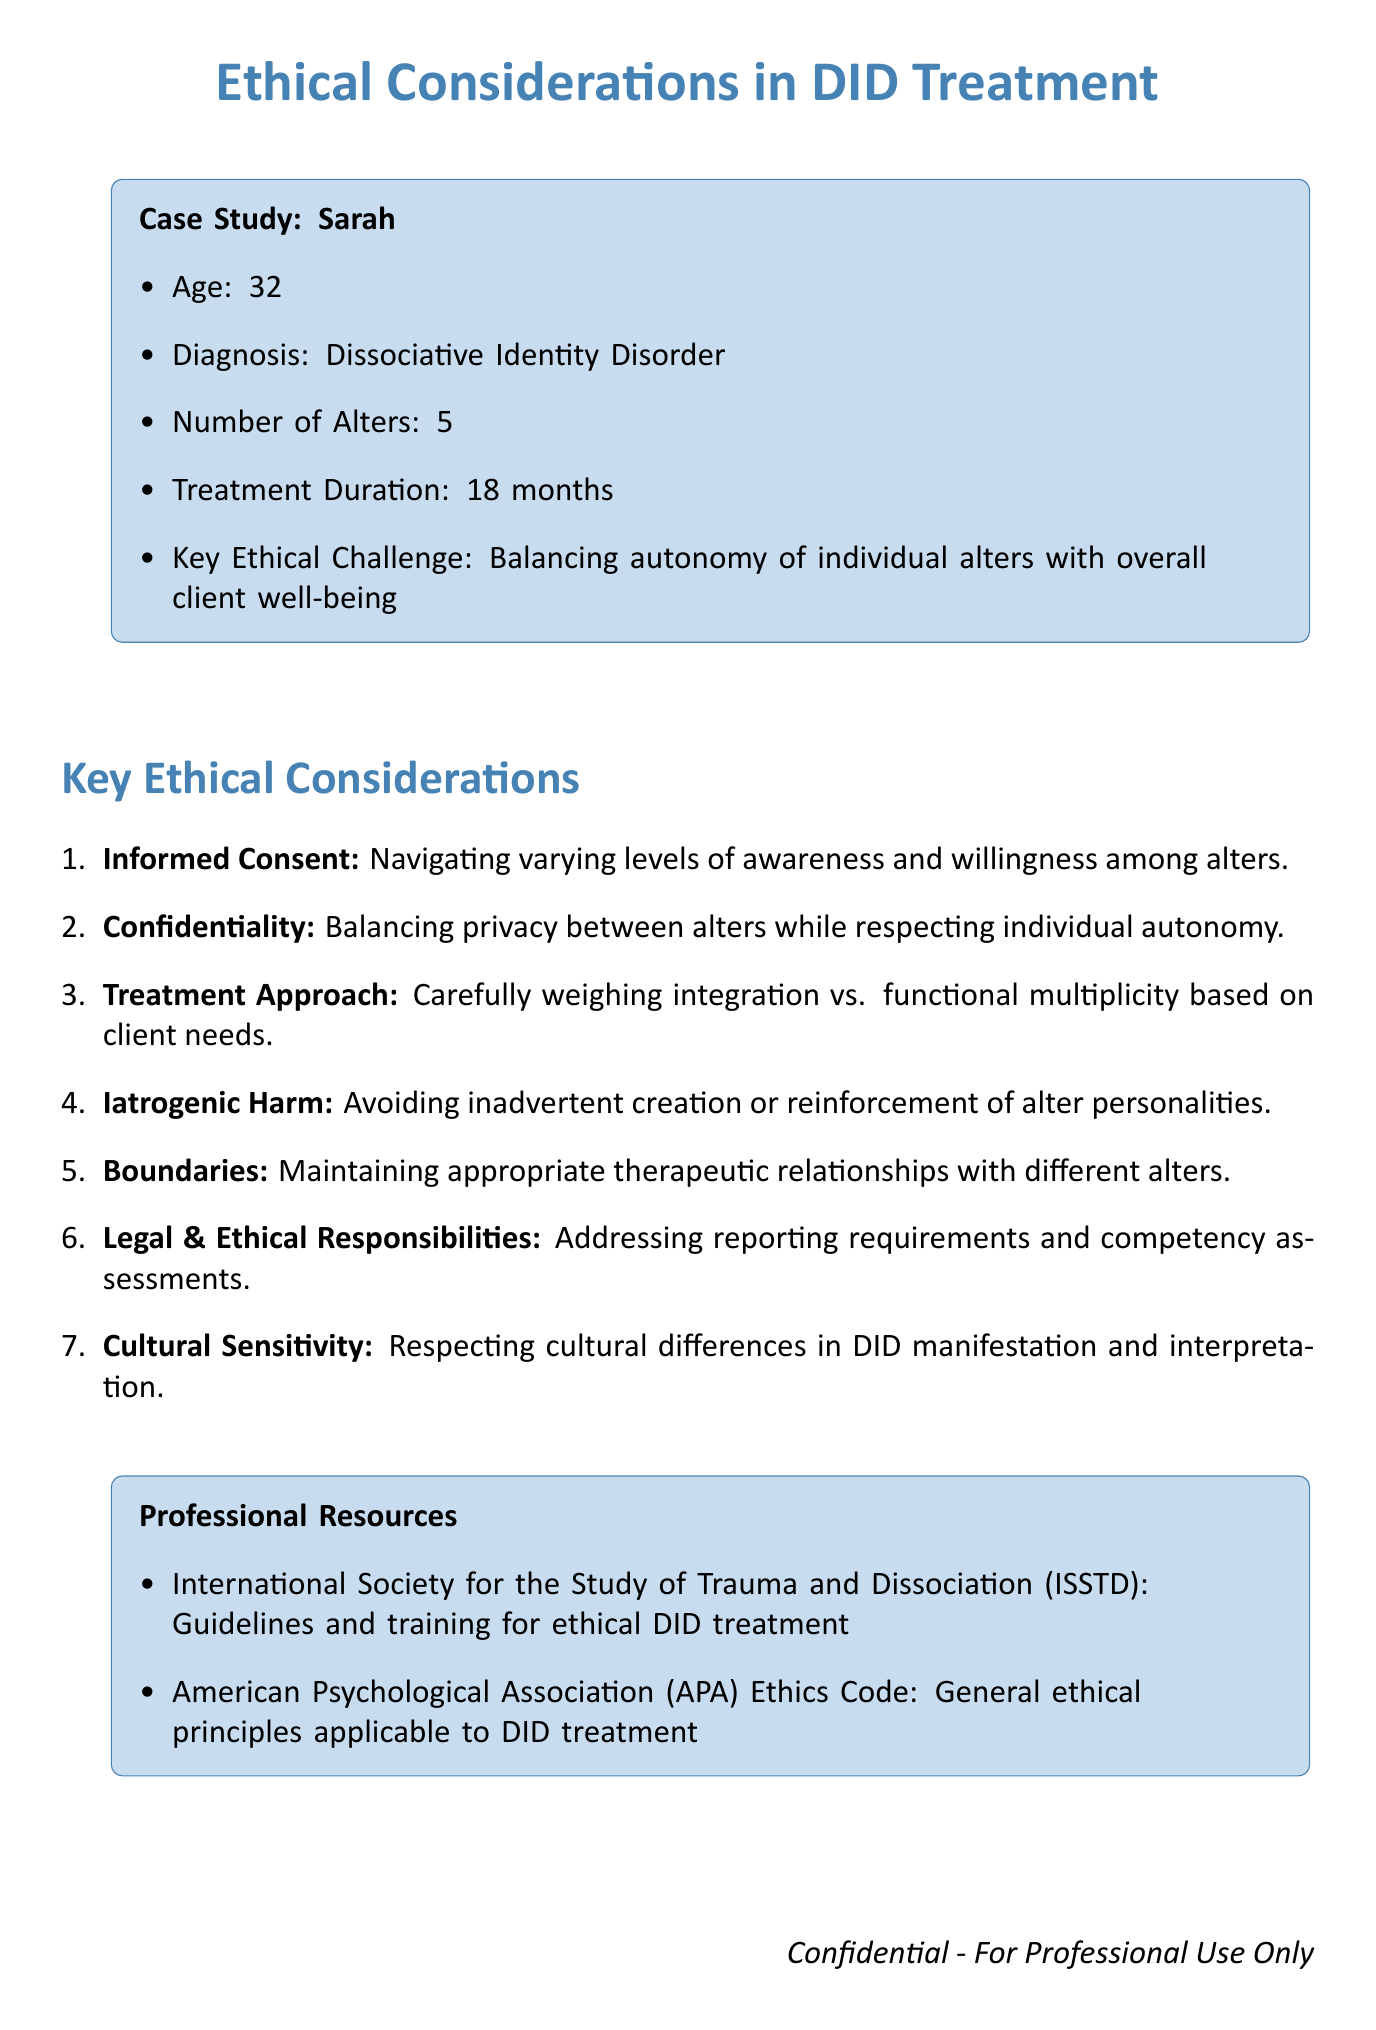What is the client's pseudonym? The client's pseudonym is clearly stated in the case study section of the document.
Answer: Sarah How many alters does the client have? The number of alters is specified in the case study of the document.
Answer: 5 What is the key ethical challenge identified in the case study? The key ethical challenge is highlighted in the case study for the client Sarah.
Answer: Balancing the autonomy of individual alters with the overall well-being of the client system What organization provides guidelines for ethical treatment of DID? The document lists professional resources, one of which provides ethical guidelines.
Answer: International Society for the Study of Trauma and Dissociation (ISSTD) What should therapists avoid to prevent iatrogenic harm? The ethical consideration discusses what therapists should be cautious about to avoid harm.
Answer: Inadvertently create or reinforce alter personalities What is one aspect of cultural sensitivity in DID treatment? The document mentions the importance of recognizing cultural differences in treatment.
Answer: Respecting cultural differences in the manifestation and interpretation of DID symptoms How long has the client been in treatment? The duration of treatment for the client is indicated in the case study section.
Answer: 18 months What ethical principle does the APA Ethics Code offer? The document mentions that the APA Ethics Code provides certain principles applicable to DID treatment.
Answer: General ethical principles applicable to DID treatment 